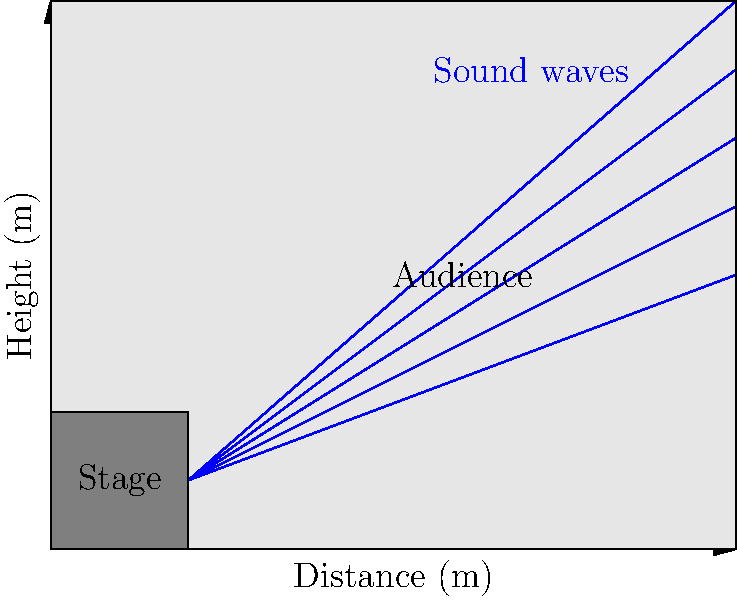In a Shinehead concert, how does the shape of the venue affect the propagation of sound waves, and what acoustic considerations should be made to ensure optimal sound quality for the audience? To understand how the shape of the venue affects sound propagation and determine acoustic considerations for optimal sound quality, let's break it down step-by-step:

1. Sound wave propagation:
   - Sound waves emanate from the stage (source) in all directions.
   - They travel through the air as longitudinal waves.

2. Reflection:
   - Sound waves reflect off hard surfaces like walls, ceiling, and floor.
   - The angle of incidence equals the angle of reflection.

3. Absorption:
   - Some materials in the venue (e.g., curtains, carpets, audience) absorb sound energy.
   - This reduces echo and reverberation.

4. Diffusion:
   - Irregular surfaces scatter sound waves in multiple directions.
   - This helps create a more even sound distribution.

5. Venue shape considerations:
   a) Ceiling height and shape:
      - Higher ceilings can cause longer reverberation times.
      - Curved ceilings can focus sound to specific areas.
   b) Wall angles:
      - Parallel walls can create standing waves and flutter echoes.
      - Angled or non-parallel walls help distribute sound more evenly.
   c) Floor slope:
      - A sloped floor helps sound reach the back of the audience more directly.

6. Acoustic treatments:
   - Use of sound-absorbing materials on walls and ceiling.
   - Installation of diffusers to scatter sound waves.
   - Proper placement of speakers and monitors.

7. Consideration for Shinehead's music:
   - Ensure clarity for vocals and reggae/hip-hop beats.
   - Balance between low-frequency response for bass and mid-high frequencies for lyrics.

8. Sound system setup:
   - Proper positioning and angling of speakers.
   - Use of delay speakers for larger venues to ensure synchronization.

To ensure optimal sound quality:
- Design the venue with non-parallel walls and an appropriate ceiling height.
- Use a combination of reflective and absorptive surfaces.
- Implement acoustic treatments like diffusers and absorbers.
- Set up the sound system to provide even coverage throughout the audience area.
- Consider the specific requirements of Shinehead's music style when tuning the system.
Answer: Non-parallel walls, balanced absorption/reflection, acoustic treatments, proper speaker placement 